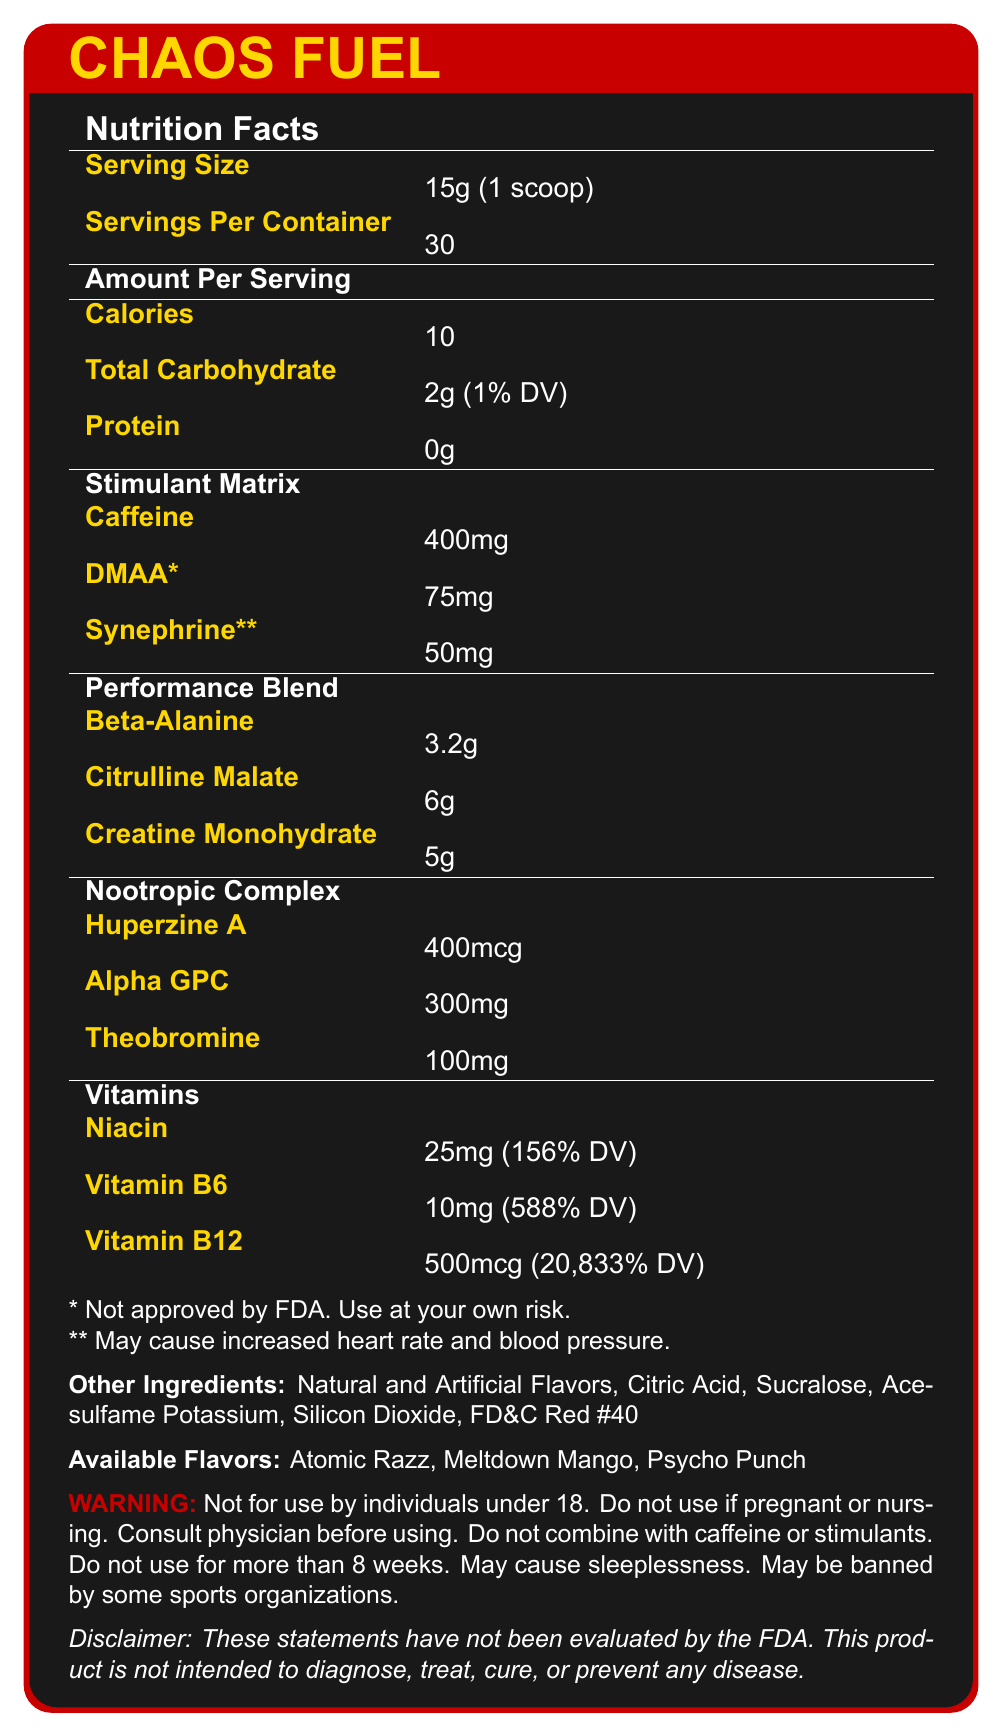what is the serving size? The serving size is stated clearly under the "Nutrition Facts" section of the document.
Answer: 15g (1 scoop) how many servings are in one container? This information is listed under "Servings Per Container".
Answer: 30 how many calories are there per serving? The number of calories per serving is mentioned under the "Amount Per Serving" section.
Answer: 10 what is the amount of caffeine per serving? The amount of caffeine is listed under the "Stimulant Matrix" section.
Answer: 400mg which ingredient has the highest percentage of daily value? The "Vitamins" section shows that Vitamin B12 has a daily value of 20,833%, which is the highest among the listed ingredients.
Answer: Vitamin B12 what are the available flavors of CHAOS FUEL? The available flavors are mentioned under the "Available Flavors" section of the document.
Answer: Atomic Razz, Meltdown Mango, Psycho Punch how much Beta-Alanine does one serving contain? The amount of Beta-Alanine is listed under the "Performance Blend" section.
Answer: 3.2g what are the stated warnings for this preworkout supplement? The warnings are listed under the "WARNING" section.
Answer: Not for use by individuals under 18. Do not use if pregnant or nursing. Consult a physician before using. Do not combine with caffeine or stimulants. Do not use for more than 8 weeks. May cause sleeplessness. May be banned by some sports organizations. what is the daily value of Niacin in CHAOS FUEL? The daily value of Niacin is provided next to its amount under the "Vitamins" section.
Answer: 156% what is the protein content per serving? The protein content is listed under the "Amount Per Serving" section.
Answer: 0g what are some of the marketing claims made for CHAOS FUEL? A. Boosts Immunity B. Experience unparalleled energy and focus C. Helps with Weight Loss D. Unleash your inner beast The document includes the marketing claims "Experience unparalleled energy and focus" and "Unleash your inner beast".
Answer: B, D which of the following is NOT one of the additional ingredients in CHAOS FUEL? A. Citric Acid B. Sucralose C. FD&C Blue #1 D. Silicon Dioxide The document lists Citric Acid, Sucralose, and FD&C Red #40, but not FD&C Blue #1.
Answer: C is DMAA approved by the FDA? The document clearly states that DMAA is not approved by the FDA.
Answer: No summarize the main idea of CHAOS FUEL's document. The document includes detailed nutrition information, ingredients, available flavors, marketing claims, and necessary warnings and disclaimers for the product.
Answer: CHAOS FUEL is an intense preworkout supplement designed for hardcore athletes. It contains high levels of stimulants and performance-enhancing ingredients, including 400mg of caffeine, 75mg of DMAA, and 50mg of synephrine, along with vitamins and nootropics. The supplement comes with several warnings and is marketed with bold claims of heightened energy and focus. when was CHAOS FUEL released? The document does not provide any information about the release date of CHAOS FUEL.
Answer: Not enough information 